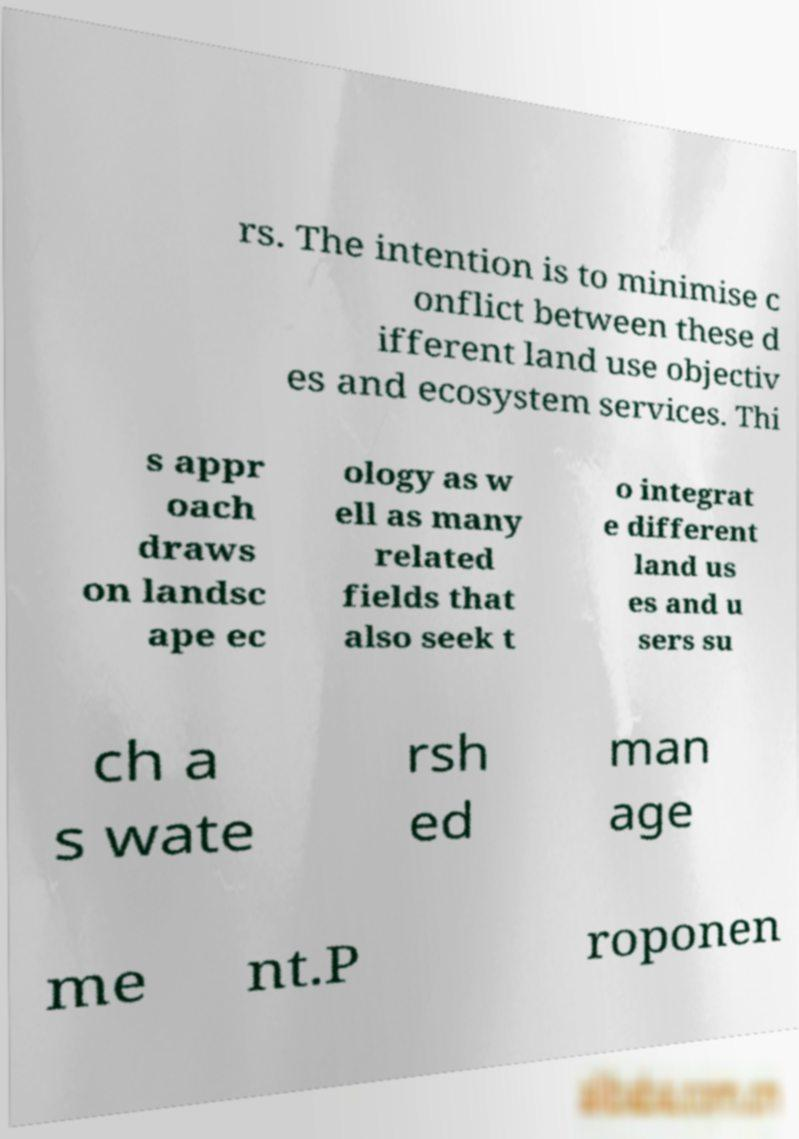For documentation purposes, I need the text within this image transcribed. Could you provide that? rs. The intention is to minimise c onflict between these d ifferent land use objectiv es and ecosystem services. Thi s appr oach draws on landsc ape ec ology as w ell as many related fields that also seek t o integrat e different land us es and u sers su ch a s wate rsh ed man age me nt.P roponen 